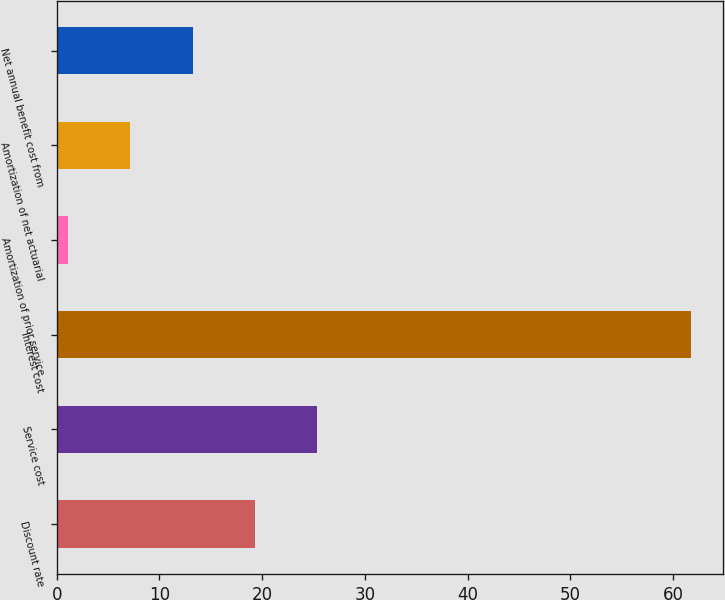<chart> <loc_0><loc_0><loc_500><loc_500><bar_chart><fcel>Discount rate<fcel>Service cost<fcel>Interest cost<fcel>Amortization of prior service<fcel>Amortization of net actuarial<fcel>Net annual benefit cost from<nl><fcel>19.31<fcel>25.38<fcel>61.8<fcel>1.1<fcel>7.17<fcel>13.24<nl></chart> 